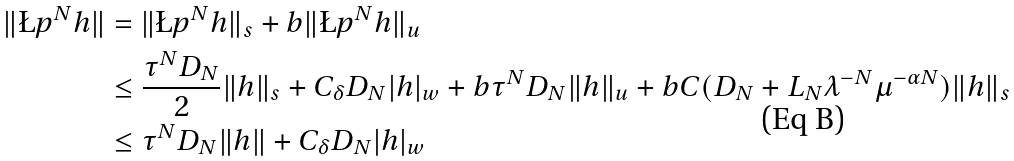<formula> <loc_0><loc_0><loc_500><loc_500>\| \L p ^ { N } h \| & = \| \L p ^ { N } h \| _ { s } + b \| \L p ^ { N } h \| _ { u } \\ & \leq \frac { \tau ^ { N } D _ { N } } 2 \| h \| _ { s } + C _ { \delta } D _ { N } | h | _ { w } + b \tau ^ { N } D _ { N } \| h \| _ { u } + b C ( D _ { N } + L _ { N } \lambda ^ { - N } \mu ^ { - \alpha N } ) \| h \| _ { s } \\ & \leq \tau ^ { N } D _ { N } \| h \| + C _ { \delta } D _ { N } | h | _ { w }</formula> 